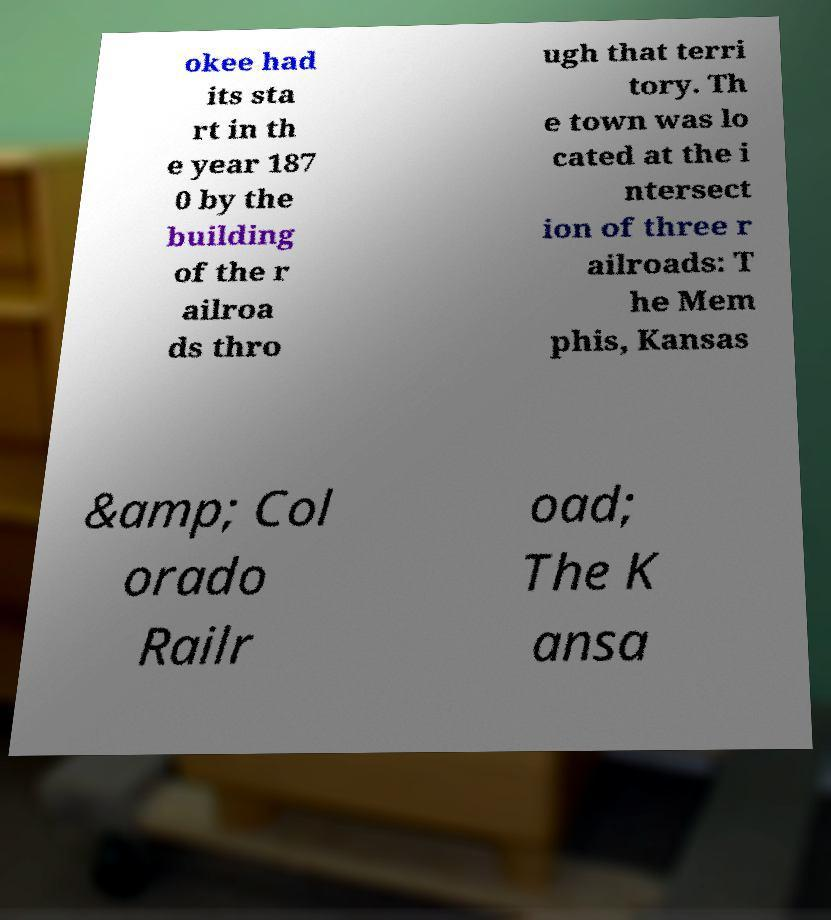Could you assist in decoding the text presented in this image and type it out clearly? okee had its sta rt in th e year 187 0 by the building of the r ailroa ds thro ugh that terri tory. Th e town was lo cated at the i ntersect ion of three r ailroads: T he Mem phis, Kansas &amp; Col orado Railr oad; The K ansa 